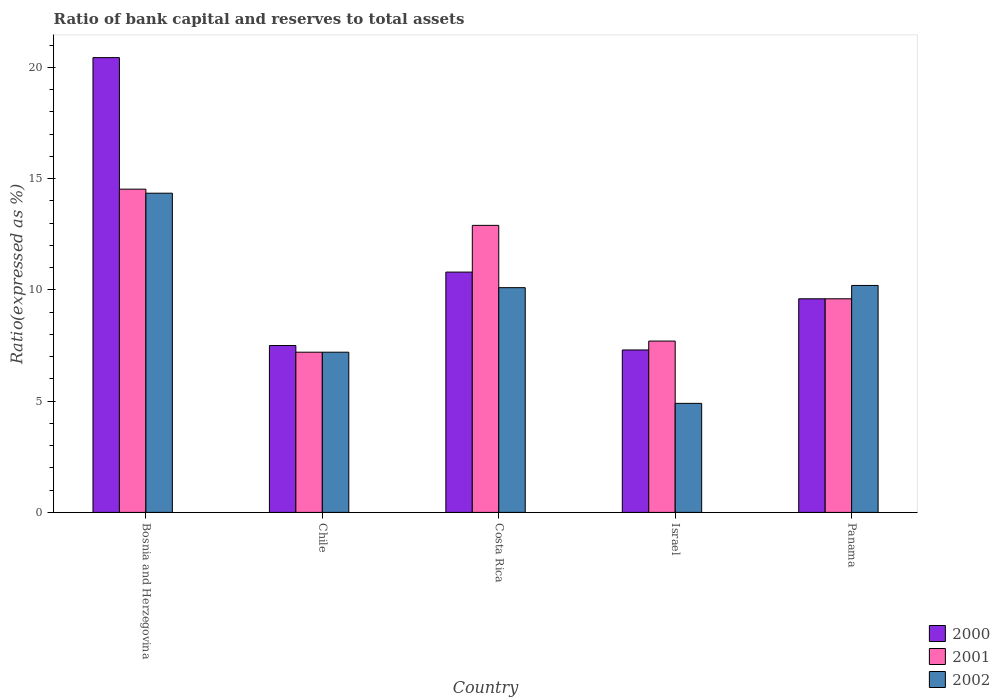How many different coloured bars are there?
Make the answer very short. 3. Are the number of bars per tick equal to the number of legend labels?
Your response must be concise. Yes. How many bars are there on the 1st tick from the left?
Ensure brevity in your answer.  3. In how many cases, is the number of bars for a given country not equal to the number of legend labels?
Ensure brevity in your answer.  0. What is the ratio of bank capital and reserves to total assets in 2001 in Bosnia and Herzegovina?
Offer a very short reply. 14.53. Across all countries, what is the maximum ratio of bank capital and reserves to total assets in 2001?
Keep it short and to the point. 14.53. Across all countries, what is the minimum ratio of bank capital and reserves to total assets in 2002?
Offer a very short reply. 4.9. In which country was the ratio of bank capital and reserves to total assets in 2002 maximum?
Provide a short and direct response. Bosnia and Herzegovina. What is the total ratio of bank capital and reserves to total assets in 2002 in the graph?
Give a very brief answer. 46.75. What is the difference between the ratio of bank capital and reserves to total assets in 2000 in Costa Rica and that in Panama?
Provide a short and direct response. 1.2. What is the difference between the ratio of bank capital and reserves to total assets in 2002 in Bosnia and Herzegovina and the ratio of bank capital and reserves to total assets in 2000 in Israel?
Offer a terse response. 7.05. What is the average ratio of bank capital and reserves to total assets in 2000 per country?
Your answer should be very brief. 11.13. What is the difference between the ratio of bank capital and reserves to total assets of/in 2000 and ratio of bank capital and reserves to total assets of/in 2002 in Chile?
Keep it short and to the point. 0.3. What is the ratio of the ratio of bank capital and reserves to total assets in 2002 in Chile to that in Panama?
Your answer should be very brief. 0.71. Is the difference between the ratio of bank capital and reserves to total assets in 2000 in Chile and Costa Rica greater than the difference between the ratio of bank capital and reserves to total assets in 2002 in Chile and Costa Rica?
Offer a terse response. No. What is the difference between the highest and the second highest ratio of bank capital and reserves to total assets in 2001?
Provide a succinct answer. -3.3. What is the difference between the highest and the lowest ratio of bank capital and reserves to total assets in 2000?
Ensure brevity in your answer.  13.14. Is the sum of the ratio of bank capital and reserves to total assets in 2002 in Bosnia and Herzegovina and Chile greater than the maximum ratio of bank capital and reserves to total assets in 2000 across all countries?
Your response must be concise. Yes. What does the 2nd bar from the left in Israel represents?
Make the answer very short. 2001. Are all the bars in the graph horizontal?
Provide a succinct answer. No. How many countries are there in the graph?
Offer a terse response. 5. Does the graph contain any zero values?
Offer a terse response. No. Where does the legend appear in the graph?
Provide a short and direct response. Bottom right. How many legend labels are there?
Your answer should be compact. 3. How are the legend labels stacked?
Give a very brief answer. Vertical. What is the title of the graph?
Your response must be concise. Ratio of bank capital and reserves to total assets. Does "2004" appear as one of the legend labels in the graph?
Offer a very short reply. No. What is the label or title of the X-axis?
Provide a short and direct response. Country. What is the label or title of the Y-axis?
Make the answer very short. Ratio(expressed as %). What is the Ratio(expressed as %) in 2000 in Bosnia and Herzegovina?
Offer a very short reply. 20.44. What is the Ratio(expressed as %) in 2001 in Bosnia and Herzegovina?
Your response must be concise. 14.53. What is the Ratio(expressed as %) in 2002 in Bosnia and Herzegovina?
Your response must be concise. 14.35. What is the Ratio(expressed as %) of 2001 in Costa Rica?
Provide a short and direct response. 12.9. What is the Ratio(expressed as %) of 2000 in Israel?
Offer a very short reply. 7.3. What is the Ratio(expressed as %) of 2001 in Israel?
Offer a terse response. 7.7. What is the Ratio(expressed as %) of 2002 in Israel?
Provide a short and direct response. 4.9. What is the Ratio(expressed as %) of 2000 in Panama?
Keep it short and to the point. 9.6. What is the Ratio(expressed as %) in 2001 in Panama?
Provide a succinct answer. 9.6. What is the Ratio(expressed as %) of 2002 in Panama?
Offer a terse response. 10.2. Across all countries, what is the maximum Ratio(expressed as %) in 2000?
Keep it short and to the point. 20.44. Across all countries, what is the maximum Ratio(expressed as %) in 2001?
Offer a very short reply. 14.53. Across all countries, what is the maximum Ratio(expressed as %) in 2002?
Give a very brief answer. 14.35. Across all countries, what is the minimum Ratio(expressed as %) of 2000?
Your response must be concise. 7.3. What is the total Ratio(expressed as %) in 2000 in the graph?
Ensure brevity in your answer.  55.64. What is the total Ratio(expressed as %) in 2001 in the graph?
Provide a succinct answer. 51.93. What is the total Ratio(expressed as %) of 2002 in the graph?
Make the answer very short. 46.75. What is the difference between the Ratio(expressed as %) in 2000 in Bosnia and Herzegovina and that in Chile?
Ensure brevity in your answer.  12.94. What is the difference between the Ratio(expressed as %) of 2001 in Bosnia and Herzegovina and that in Chile?
Offer a very short reply. 7.33. What is the difference between the Ratio(expressed as %) of 2002 in Bosnia and Herzegovina and that in Chile?
Provide a succinct answer. 7.15. What is the difference between the Ratio(expressed as %) in 2000 in Bosnia and Herzegovina and that in Costa Rica?
Provide a succinct answer. 9.64. What is the difference between the Ratio(expressed as %) in 2001 in Bosnia and Herzegovina and that in Costa Rica?
Keep it short and to the point. 1.63. What is the difference between the Ratio(expressed as %) in 2002 in Bosnia and Herzegovina and that in Costa Rica?
Your response must be concise. 4.25. What is the difference between the Ratio(expressed as %) in 2000 in Bosnia and Herzegovina and that in Israel?
Provide a succinct answer. 13.14. What is the difference between the Ratio(expressed as %) in 2001 in Bosnia and Herzegovina and that in Israel?
Your response must be concise. 6.83. What is the difference between the Ratio(expressed as %) of 2002 in Bosnia and Herzegovina and that in Israel?
Your answer should be very brief. 9.45. What is the difference between the Ratio(expressed as %) in 2000 in Bosnia and Herzegovina and that in Panama?
Provide a short and direct response. 10.84. What is the difference between the Ratio(expressed as %) in 2001 in Bosnia and Herzegovina and that in Panama?
Keep it short and to the point. 4.93. What is the difference between the Ratio(expressed as %) of 2002 in Bosnia and Herzegovina and that in Panama?
Your response must be concise. 4.15. What is the difference between the Ratio(expressed as %) in 2000 in Chile and that in Costa Rica?
Make the answer very short. -3.3. What is the difference between the Ratio(expressed as %) of 2000 in Chile and that in Israel?
Your response must be concise. 0.2. What is the difference between the Ratio(expressed as %) in 2002 in Chile and that in Israel?
Ensure brevity in your answer.  2.3. What is the difference between the Ratio(expressed as %) of 2000 in Chile and that in Panama?
Keep it short and to the point. -2.1. What is the difference between the Ratio(expressed as %) of 2001 in Chile and that in Panama?
Your response must be concise. -2.4. What is the difference between the Ratio(expressed as %) in 2002 in Chile and that in Panama?
Your answer should be compact. -3. What is the difference between the Ratio(expressed as %) of 2000 in Costa Rica and that in Israel?
Ensure brevity in your answer.  3.5. What is the difference between the Ratio(expressed as %) of 2001 in Costa Rica and that in Israel?
Provide a short and direct response. 5.2. What is the difference between the Ratio(expressed as %) in 2002 in Costa Rica and that in Panama?
Offer a very short reply. -0.1. What is the difference between the Ratio(expressed as %) of 2000 in Bosnia and Herzegovina and the Ratio(expressed as %) of 2001 in Chile?
Provide a succinct answer. 13.24. What is the difference between the Ratio(expressed as %) in 2000 in Bosnia and Herzegovina and the Ratio(expressed as %) in 2002 in Chile?
Your answer should be compact. 13.24. What is the difference between the Ratio(expressed as %) in 2001 in Bosnia and Herzegovina and the Ratio(expressed as %) in 2002 in Chile?
Ensure brevity in your answer.  7.33. What is the difference between the Ratio(expressed as %) in 2000 in Bosnia and Herzegovina and the Ratio(expressed as %) in 2001 in Costa Rica?
Provide a succinct answer. 7.54. What is the difference between the Ratio(expressed as %) in 2000 in Bosnia and Herzegovina and the Ratio(expressed as %) in 2002 in Costa Rica?
Provide a succinct answer. 10.34. What is the difference between the Ratio(expressed as %) of 2001 in Bosnia and Herzegovina and the Ratio(expressed as %) of 2002 in Costa Rica?
Offer a very short reply. 4.43. What is the difference between the Ratio(expressed as %) of 2000 in Bosnia and Herzegovina and the Ratio(expressed as %) of 2001 in Israel?
Ensure brevity in your answer.  12.74. What is the difference between the Ratio(expressed as %) of 2000 in Bosnia and Herzegovina and the Ratio(expressed as %) of 2002 in Israel?
Give a very brief answer. 15.54. What is the difference between the Ratio(expressed as %) of 2001 in Bosnia and Herzegovina and the Ratio(expressed as %) of 2002 in Israel?
Ensure brevity in your answer.  9.63. What is the difference between the Ratio(expressed as %) in 2000 in Bosnia and Herzegovina and the Ratio(expressed as %) in 2001 in Panama?
Provide a short and direct response. 10.84. What is the difference between the Ratio(expressed as %) of 2000 in Bosnia and Herzegovina and the Ratio(expressed as %) of 2002 in Panama?
Make the answer very short. 10.24. What is the difference between the Ratio(expressed as %) in 2001 in Bosnia and Herzegovina and the Ratio(expressed as %) in 2002 in Panama?
Offer a terse response. 4.33. What is the difference between the Ratio(expressed as %) of 2000 in Chile and the Ratio(expressed as %) of 2001 in Costa Rica?
Offer a very short reply. -5.4. What is the difference between the Ratio(expressed as %) in 2001 in Chile and the Ratio(expressed as %) in 2002 in Costa Rica?
Provide a short and direct response. -2.9. What is the difference between the Ratio(expressed as %) of 2001 in Chile and the Ratio(expressed as %) of 2002 in Panama?
Provide a succinct answer. -3. What is the difference between the Ratio(expressed as %) in 2000 in Israel and the Ratio(expressed as %) in 2002 in Panama?
Offer a very short reply. -2.9. What is the difference between the Ratio(expressed as %) of 2001 in Israel and the Ratio(expressed as %) of 2002 in Panama?
Your answer should be very brief. -2.5. What is the average Ratio(expressed as %) in 2000 per country?
Your answer should be very brief. 11.13. What is the average Ratio(expressed as %) of 2001 per country?
Keep it short and to the point. 10.39. What is the average Ratio(expressed as %) in 2002 per country?
Give a very brief answer. 9.35. What is the difference between the Ratio(expressed as %) of 2000 and Ratio(expressed as %) of 2001 in Bosnia and Herzegovina?
Your answer should be compact. 5.91. What is the difference between the Ratio(expressed as %) of 2000 and Ratio(expressed as %) of 2002 in Bosnia and Herzegovina?
Ensure brevity in your answer.  6.09. What is the difference between the Ratio(expressed as %) of 2001 and Ratio(expressed as %) of 2002 in Bosnia and Herzegovina?
Keep it short and to the point. 0.18. What is the difference between the Ratio(expressed as %) in 2000 and Ratio(expressed as %) in 2001 in Chile?
Your answer should be compact. 0.3. What is the difference between the Ratio(expressed as %) of 2000 and Ratio(expressed as %) of 2002 in Chile?
Ensure brevity in your answer.  0.3. What is the difference between the Ratio(expressed as %) of 2001 and Ratio(expressed as %) of 2002 in Costa Rica?
Your response must be concise. 2.8. What is the difference between the Ratio(expressed as %) of 2001 and Ratio(expressed as %) of 2002 in Israel?
Provide a short and direct response. 2.8. What is the difference between the Ratio(expressed as %) in 2000 and Ratio(expressed as %) in 2002 in Panama?
Make the answer very short. -0.6. What is the difference between the Ratio(expressed as %) in 2001 and Ratio(expressed as %) in 2002 in Panama?
Your answer should be very brief. -0.6. What is the ratio of the Ratio(expressed as %) of 2000 in Bosnia and Herzegovina to that in Chile?
Provide a short and direct response. 2.73. What is the ratio of the Ratio(expressed as %) in 2001 in Bosnia and Herzegovina to that in Chile?
Your answer should be compact. 2.02. What is the ratio of the Ratio(expressed as %) in 2002 in Bosnia and Herzegovina to that in Chile?
Your response must be concise. 1.99. What is the ratio of the Ratio(expressed as %) in 2000 in Bosnia and Herzegovina to that in Costa Rica?
Provide a short and direct response. 1.89. What is the ratio of the Ratio(expressed as %) of 2001 in Bosnia and Herzegovina to that in Costa Rica?
Your answer should be compact. 1.13. What is the ratio of the Ratio(expressed as %) of 2002 in Bosnia and Herzegovina to that in Costa Rica?
Your answer should be compact. 1.42. What is the ratio of the Ratio(expressed as %) in 2000 in Bosnia and Herzegovina to that in Israel?
Your response must be concise. 2.8. What is the ratio of the Ratio(expressed as %) of 2001 in Bosnia and Herzegovina to that in Israel?
Offer a terse response. 1.89. What is the ratio of the Ratio(expressed as %) of 2002 in Bosnia and Herzegovina to that in Israel?
Give a very brief answer. 2.93. What is the ratio of the Ratio(expressed as %) of 2000 in Bosnia and Herzegovina to that in Panama?
Provide a succinct answer. 2.13. What is the ratio of the Ratio(expressed as %) in 2001 in Bosnia and Herzegovina to that in Panama?
Your response must be concise. 1.51. What is the ratio of the Ratio(expressed as %) of 2002 in Bosnia and Herzegovina to that in Panama?
Ensure brevity in your answer.  1.41. What is the ratio of the Ratio(expressed as %) in 2000 in Chile to that in Costa Rica?
Provide a short and direct response. 0.69. What is the ratio of the Ratio(expressed as %) of 2001 in Chile to that in Costa Rica?
Provide a short and direct response. 0.56. What is the ratio of the Ratio(expressed as %) of 2002 in Chile to that in Costa Rica?
Your response must be concise. 0.71. What is the ratio of the Ratio(expressed as %) in 2000 in Chile to that in Israel?
Provide a succinct answer. 1.03. What is the ratio of the Ratio(expressed as %) in 2001 in Chile to that in Israel?
Offer a terse response. 0.94. What is the ratio of the Ratio(expressed as %) of 2002 in Chile to that in Israel?
Keep it short and to the point. 1.47. What is the ratio of the Ratio(expressed as %) in 2000 in Chile to that in Panama?
Keep it short and to the point. 0.78. What is the ratio of the Ratio(expressed as %) of 2002 in Chile to that in Panama?
Offer a very short reply. 0.71. What is the ratio of the Ratio(expressed as %) of 2000 in Costa Rica to that in Israel?
Your answer should be very brief. 1.48. What is the ratio of the Ratio(expressed as %) in 2001 in Costa Rica to that in Israel?
Provide a short and direct response. 1.68. What is the ratio of the Ratio(expressed as %) in 2002 in Costa Rica to that in Israel?
Give a very brief answer. 2.06. What is the ratio of the Ratio(expressed as %) of 2001 in Costa Rica to that in Panama?
Your response must be concise. 1.34. What is the ratio of the Ratio(expressed as %) of 2002 in Costa Rica to that in Panama?
Give a very brief answer. 0.99. What is the ratio of the Ratio(expressed as %) of 2000 in Israel to that in Panama?
Offer a terse response. 0.76. What is the ratio of the Ratio(expressed as %) in 2001 in Israel to that in Panama?
Provide a short and direct response. 0.8. What is the ratio of the Ratio(expressed as %) of 2002 in Israel to that in Panama?
Your answer should be compact. 0.48. What is the difference between the highest and the second highest Ratio(expressed as %) of 2000?
Make the answer very short. 9.64. What is the difference between the highest and the second highest Ratio(expressed as %) in 2001?
Provide a succinct answer. 1.63. What is the difference between the highest and the second highest Ratio(expressed as %) in 2002?
Provide a short and direct response. 4.15. What is the difference between the highest and the lowest Ratio(expressed as %) of 2000?
Your response must be concise. 13.14. What is the difference between the highest and the lowest Ratio(expressed as %) of 2001?
Your answer should be very brief. 7.33. What is the difference between the highest and the lowest Ratio(expressed as %) in 2002?
Offer a terse response. 9.45. 